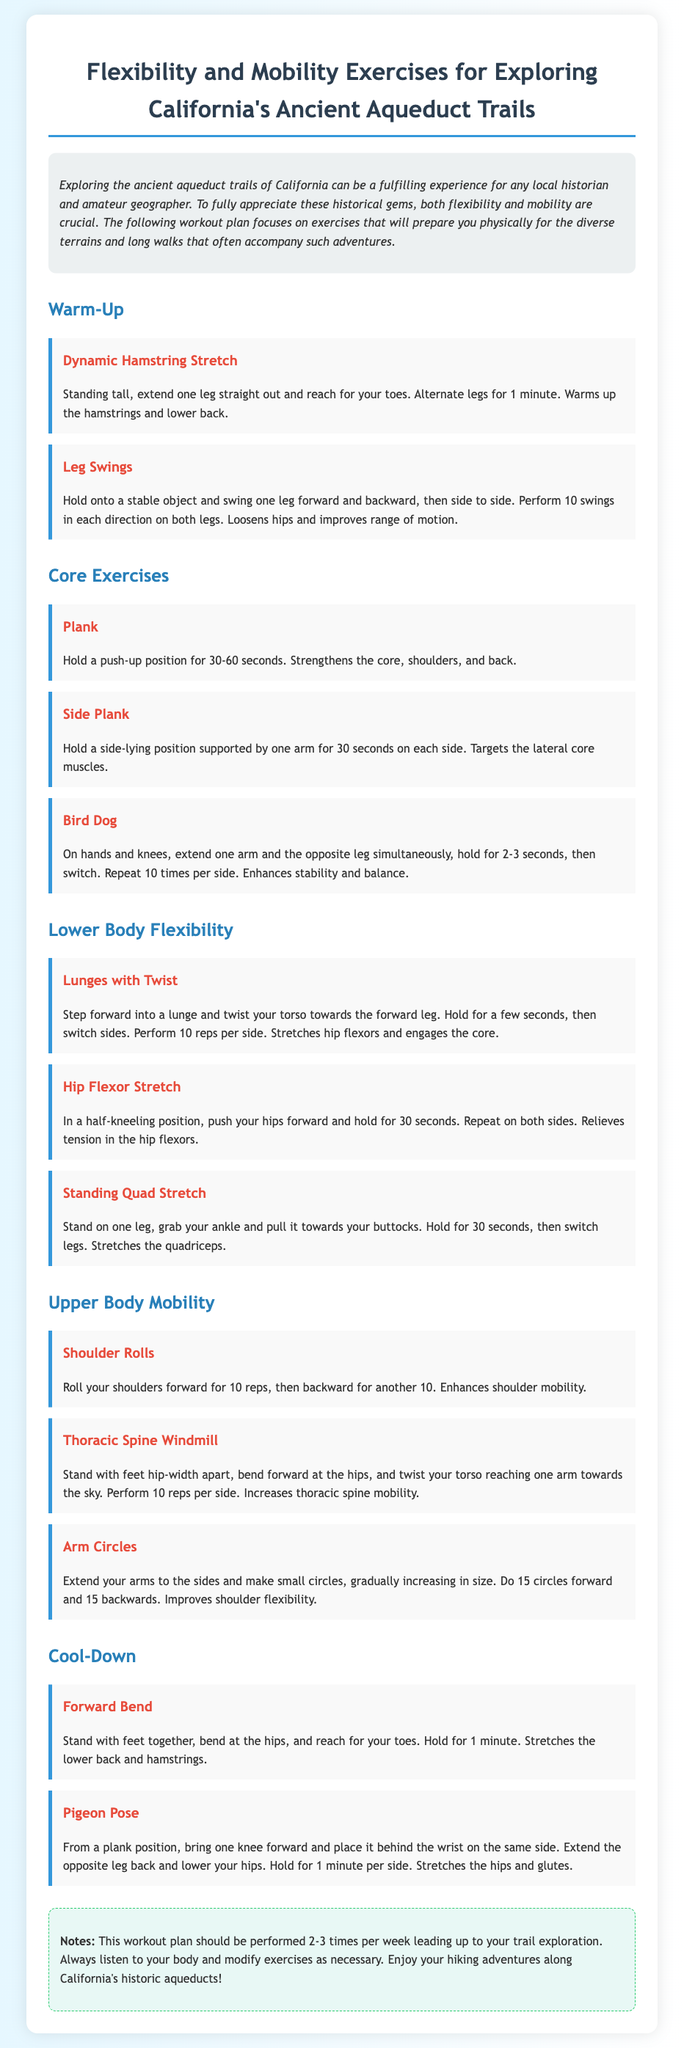What is the title of the document? The title of the document is located in the header section and specifies the focus of the content.
Answer: Flexibility and Mobility Exercises for Exploring California's Ancient Aqueduct Trails How many warm-up exercises are listed? The section for warm-up exercises includes specific exercises that are designed to prepare for the main workout.
Answer: 2 What exercise follows the 'Bird Dog' in the core exercises section? The exercises are listed in a clear sequence, and the exercise that follows 'Bird Dog' is found directly below it.
Answer: Lunges with Twist How long should you hold the plank exercise? The duration for holding the plank exercise is explicitly stated in the description of that exercise.
Answer: 30-60 seconds What is the purpose of the 'Pigeon Pose'? The document indicates the benefits of the exercises, and this pose specifically targets certain areas of the body.
Answer: Stretches the hips and glutes How often should the workout plan be performed? The recommendation for frequency is noted in the notes section of the document.
Answer: 2-3 times per week What type of stretch is the 'Standing Quad Stretch'? This exercise is categorized based on its specific focus in the document, which describes its benefits.
Answer: Flexibility What part of the body does the 'Thoracic Spine Windmill' target? The document specifies the intended outcome of the exercise, focusing on a specific body area.
Answer: Thoracic spine mobility What color is used for the background of the container? The document describes the visual design elements, including the background color of the main content area.
Answer: White 